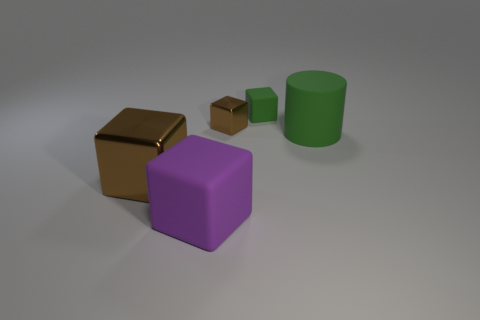Is the color of the small shiny object the same as the matte cube right of the tiny metal cube?
Your answer should be very brief. No. Are there any other things that have the same material as the tiny brown object?
Your answer should be compact. Yes. There is a rubber object that is in front of the large object right of the purple matte object; what is its shape?
Give a very brief answer. Cube. The matte cube that is the same color as the cylinder is what size?
Your answer should be compact. Small. Is the shape of the large rubber thing right of the purple rubber block the same as  the small green object?
Your answer should be very brief. No. Is the number of small green rubber things that are behind the purple matte thing greater than the number of green matte cylinders that are in front of the large cylinder?
Your answer should be compact. Yes. How many big metallic objects are in front of the brown shiny thing that is in front of the green rubber cylinder?
Your answer should be very brief. 0. What is the material of the other cube that is the same color as the large shiny block?
Ensure brevity in your answer.  Metal. What number of other things are there of the same color as the rubber cylinder?
Make the answer very short. 1. What color is the matte thing behind the green rubber object in front of the tiny brown object?
Your answer should be very brief. Green. 